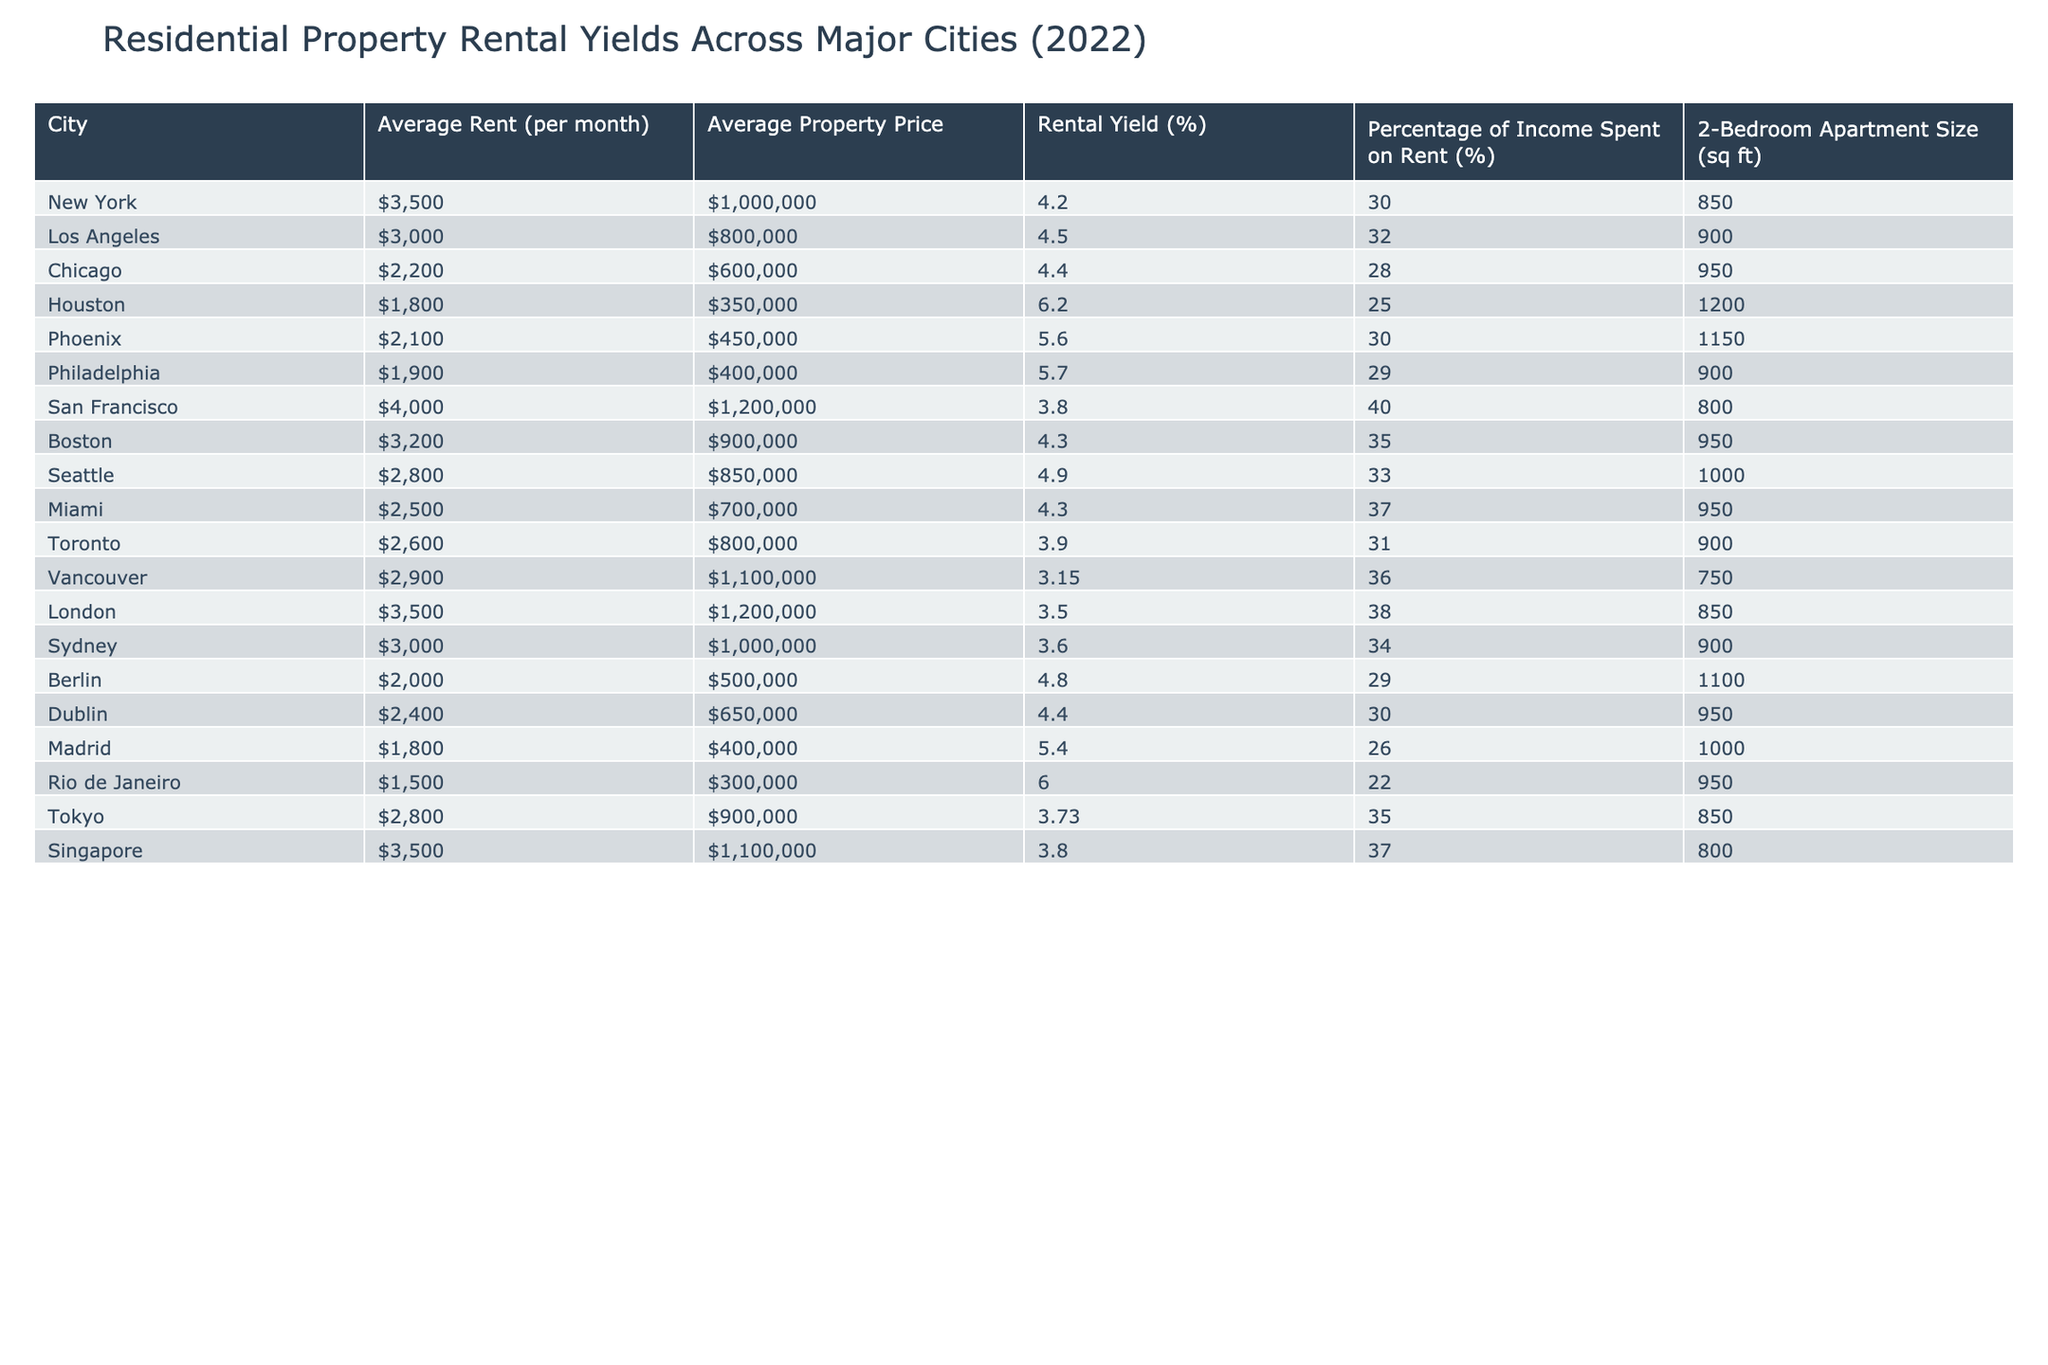What is the rental yield for Houston? The rental yield for Houston is directly listed in the table as 6.20%.
Answer: 6.20% Which city has the highest average property price? The table indicates that San Francisco and London both have the highest average property price of $1,200,000.
Answer: San Francisco and London What is the average rent for a 2-bedroom apartment in Berlin? The average rent for a 2-bedroom apartment in Berlin is given as $2,000 per month in the table.
Answer: $2,000 Calculate the rental yield difference between Miami and Philadelphia. The rental yield for Miami is 4.30%, while Philadelphia's is 5.70%. The difference is 5.70% - 4.30% = 1.40%.
Answer: 1.40% Is the percentage of income spent on rent higher in Tokyo compared to Chicago? The percentage spent on rent in Tokyo is 35% while in Chicago it is 28%, making it true that Tokyo has a higher percentage.
Answer: Yes Which city has the largest average size for a 2-bedroom apartment? By comparing the 2-bedroom apartment sizes listed in the table, Houston has the largest size at 1,200 sq ft.
Answer: Houston What is the average rental yield for the cities with prices over $1,000,000? The cities above $1,000,000 (San Francisco, London, and Vancouver) have rental yields of 3.80%, 3.50%, and 3.15%, respectively. Average is (3.80 + 3.50 + 3.15) / 3 = 3.48%.
Answer: 3.48% Which city has the lowest percentage of income spent on rent? The table shows that Rio de Janeiro has the lowest percentage of income spent on rent at 22%.
Answer: 22% Calculate the median rental yield of all cities listed. Listing the rental yields, they are: 4.20, 4.50, 4.40, 6.20, 5.60, 5.70, 3.80, 4.30, 4.90, 4.30, 3.90, 3.15, 3.50, 3.60, 4.80, 4.40, 5.40, 6.00, 3.73, 3.80. When sorted, the median is the average of the 10th and 11th yields: (4.30 + 4.40) / 2 = 4.35%.
Answer: 4.35% Is the average rent in Chicago higher than in Toronto? The average rent in Chicago is $2,200, while in Toronto it is $2,600, making the statement false regarding Chicago.
Answer: No 